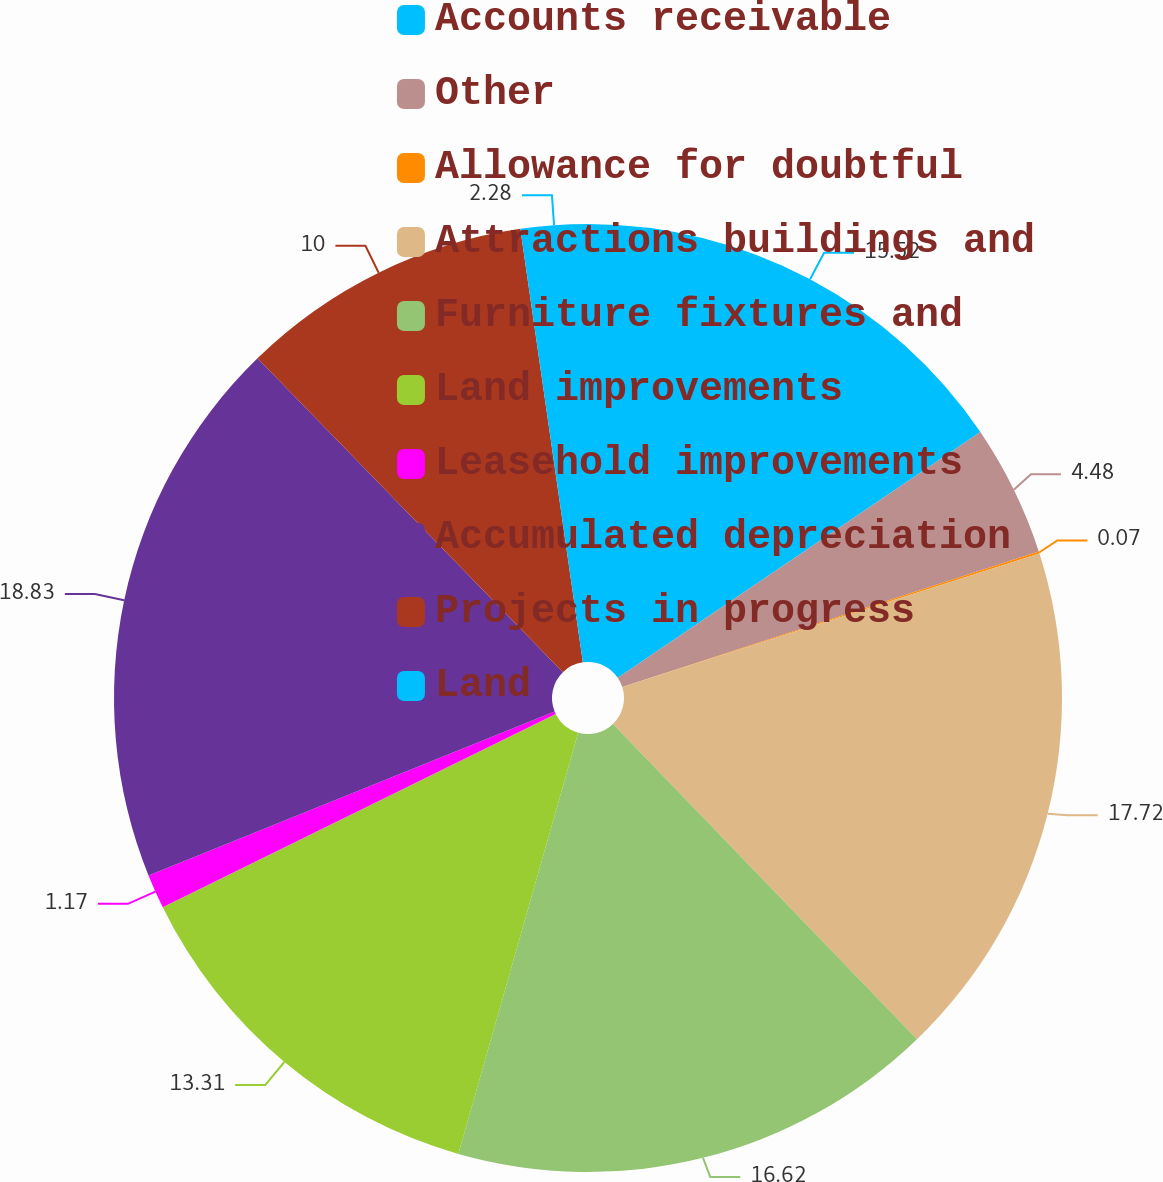Convert chart. <chart><loc_0><loc_0><loc_500><loc_500><pie_chart><fcel>Accounts receivable<fcel>Other<fcel>Allowance for doubtful<fcel>Attractions buildings and<fcel>Furniture fixtures and<fcel>Land improvements<fcel>Leasehold improvements<fcel>Accumulated depreciation<fcel>Projects in progress<fcel>Land<nl><fcel>15.52%<fcel>4.48%<fcel>0.07%<fcel>17.72%<fcel>16.62%<fcel>13.31%<fcel>1.17%<fcel>18.83%<fcel>10.0%<fcel>2.28%<nl></chart> 